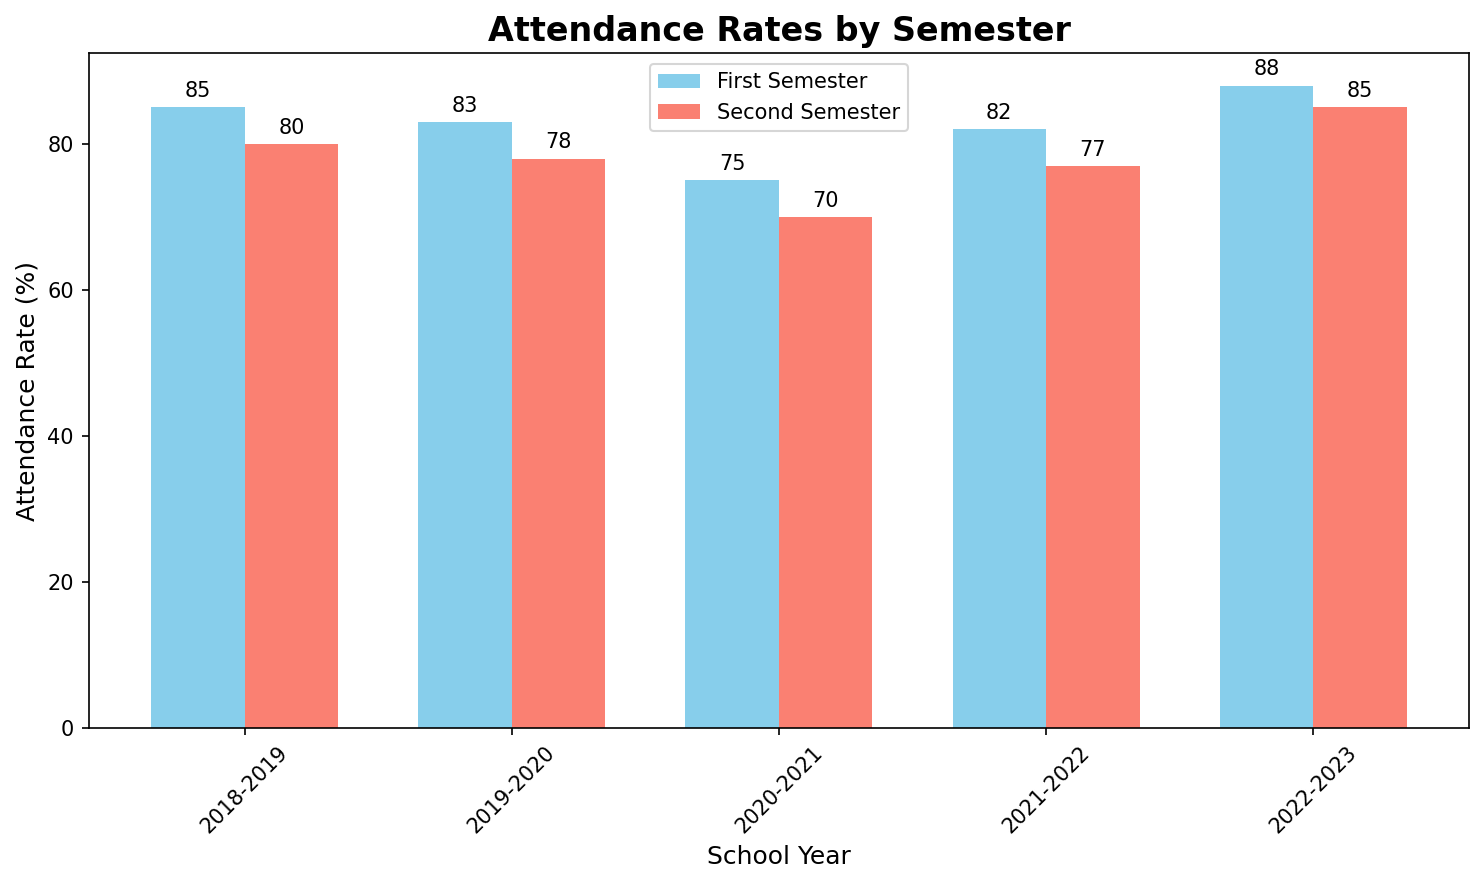What is the attendance rate for the second semester in the 2020-2021 school year? The attendance rate for the second semester in the 2020-2021 school year can be identified by looking at the second semester bar corresponding to 2020-2021.
Answer: 70 How does the first semester attendance rate in 2018-2019 compare to the second semester attendance rate in 2018-2019? To compare the attendance rates, look at both bars for 2018-2019. The first semester's attendance rate is 85%, and the second semester's is 80%.
Answer: 85 is greater What is the average attendance rate for the entire 2022-2023 school year? The average can be calculated by finding the sum of first and second semesters (88 + 85) and then dividing by 2.
Answer: (88 + 85) / 2 = 86.5 Which school year had the highest first semester attendance rate? The highest first semester attendance rate can be found by comparing the heights of all "skyblue" bars across the school years. The highest rate is 88% in 2022-2023.
Answer: 2022-2023 What is the difference in attendance rate between the first and second semesters of the 2019-2020 school year? The difference between the attendance rates is found by subtracting the second semester rate from the first semester rate (83% - 78%).
Answer: 83 - 78 = 5 How does the attendance trend from the first to second semesters look from 2020-2021 to 2022-2023? Analyzing the attendance trend involves observing if the attendance rates increase, decrease, or remain constant from the first to the second semester for these years.
Answer: Decreasing What is the overall trend in attendance rates from 2018-2019 to 2022-2023? The overall trend can be deduced by observing the general rise or fall in bar heights from 2018-2019 to 2022-2023, for both semesters.
Answer: Declining till 2020-2021, then rising 